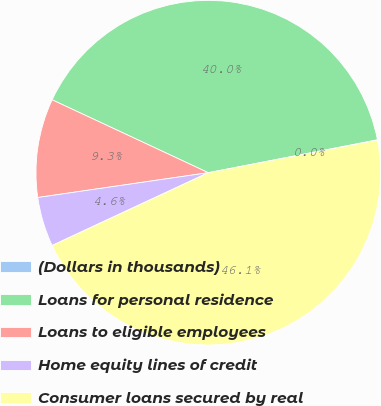Convert chart to OTSL. <chart><loc_0><loc_0><loc_500><loc_500><pie_chart><fcel>(Dollars in thousands)<fcel>Loans for personal residence<fcel>Loans to eligible employees<fcel>Home equity lines of credit<fcel>Consumer loans secured by real<nl><fcel>0.04%<fcel>39.98%<fcel>9.25%<fcel>4.64%<fcel>46.08%<nl></chart> 